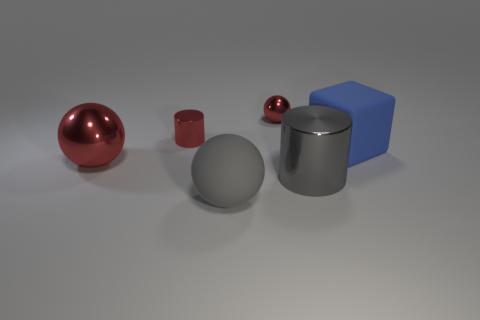Is the ball behind the matte cube made of the same material as the blue cube?
Provide a short and direct response. No. Are there fewer balls on the left side of the big gray rubber ball than blue cylinders?
Offer a terse response. No. There is a small metal object in front of the tiny metal sphere; what is its shape?
Offer a terse response. Cylinder. There is a gray metallic thing that is the same size as the blue rubber cube; what is its shape?
Make the answer very short. Cylinder. Are there any other big blue objects of the same shape as the large blue object?
Keep it short and to the point. No. Does the rubber thing that is in front of the large blue object have the same shape as the large shiny thing in front of the large red metallic ball?
Provide a short and direct response. No. What is the material of the blue cube that is the same size as the matte sphere?
Offer a very short reply. Rubber. How many other things are made of the same material as the large gray ball?
Make the answer very short. 1. The rubber thing that is in front of the large sphere to the left of the rubber sphere is what shape?
Ensure brevity in your answer.  Sphere. What number of objects are large green rubber objects or big things on the left side of the big cube?
Your answer should be compact. 3. 